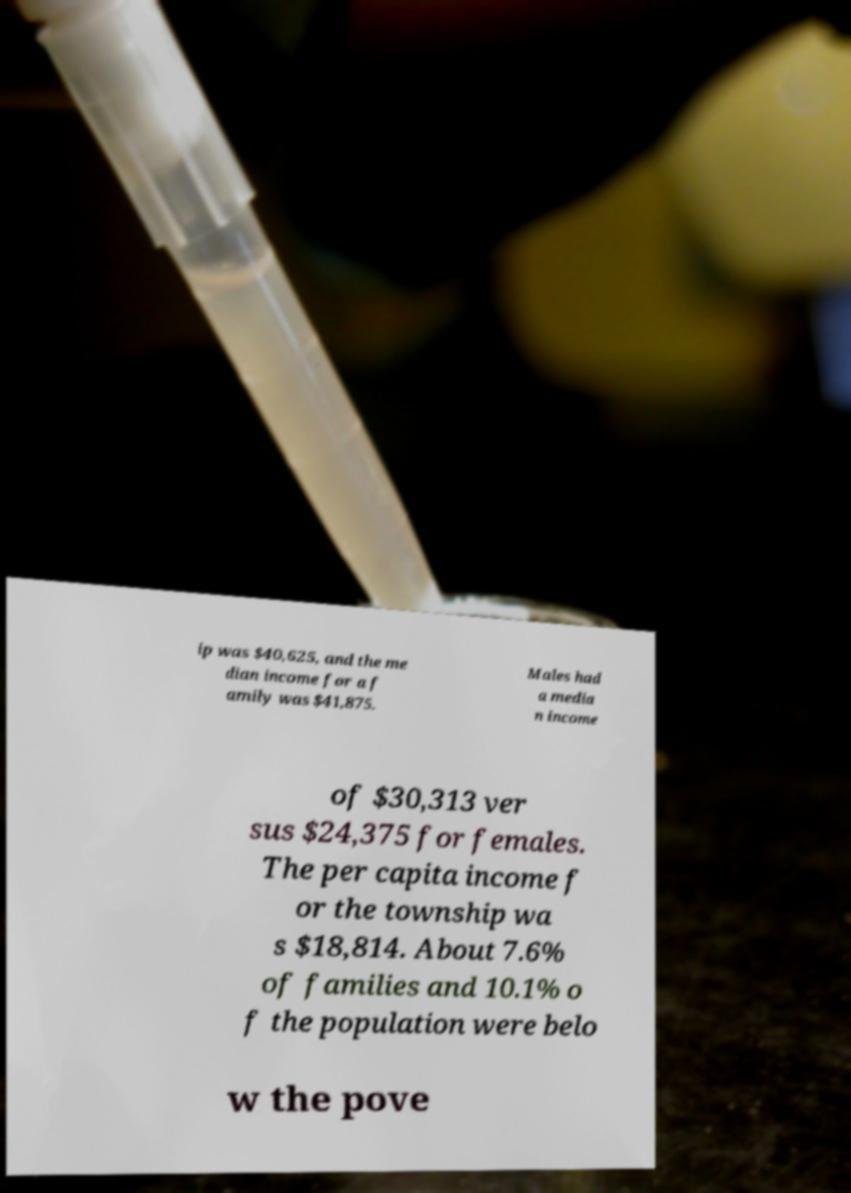I need the written content from this picture converted into text. Can you do that? ip was $40,625, and the me dian income for a f amily was $41,875. Males had a media n income of $30,313 ver sus $24,375 for females. The per capita income f or the township wa s $18,814. About 7.6% of families and 10.1% o f the population were belo w the pove 